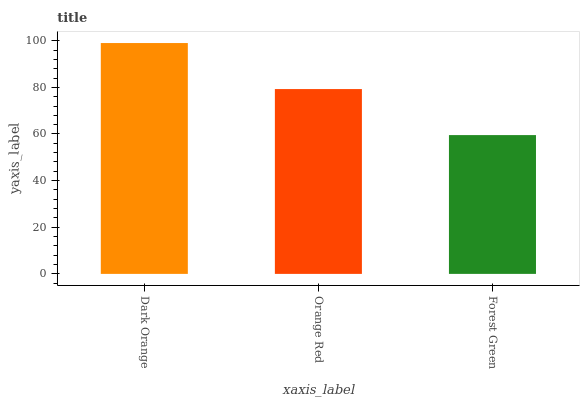Is Forest Green the minimum?
Answer yes or no. Yes. Is Dark Orange the maximum?
Answer yes or no. Yes. Is Orange Red the minimum?
Answer yes or no. No. Is Orange Red the maximum?
Answer yes or no. No. Is Dark Orange greater than Orange Red?
Answer yes or no. Yes. Is Orange Red less than Dark Orange?
Answer yes or no. Yes. Is Orange Red greater than Dark Orange?
Answer yes or no. No. Is Dark Orange less than Orange Red?
Answer yes or no. No. Is Orange Red the high median?
Answer yes or no. Yes. Is Orange Red the low median?
Answer yes or no. Yes. Is Dark Orange the high median?
Answer yes or no. No. Is Forest Green the low median?
Answer yes or no. No. 